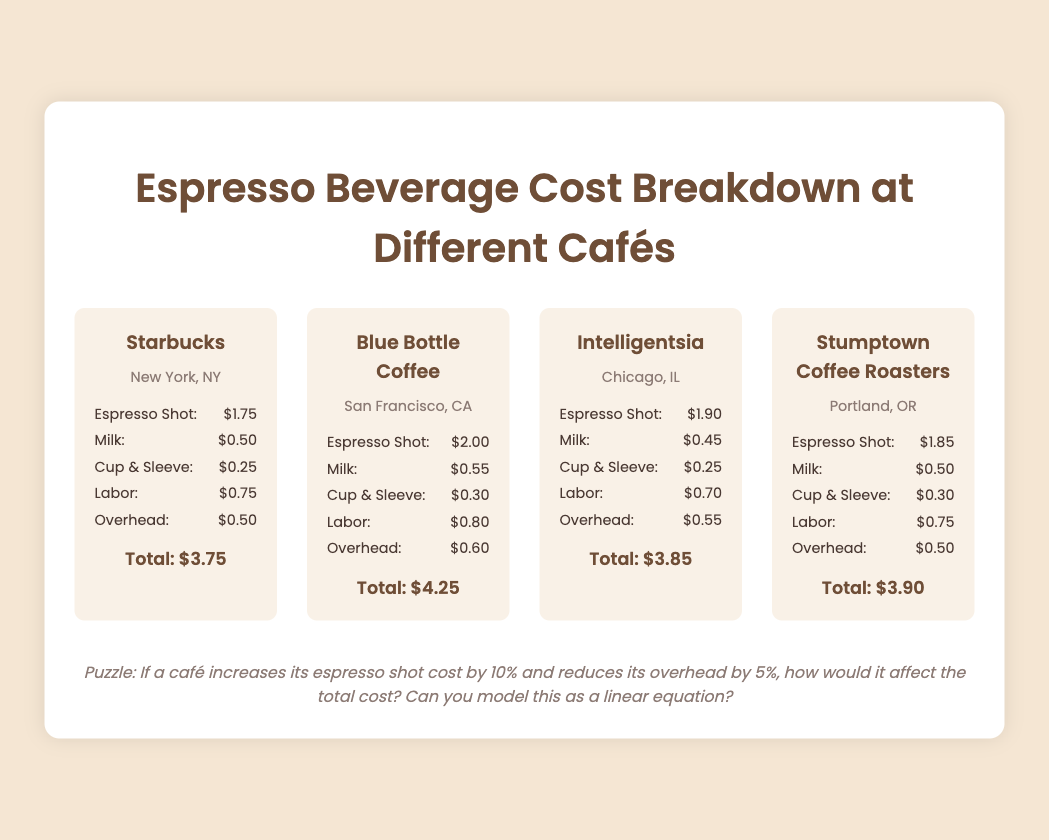What is the total cost of an espresso drink at Starbucks? The total cost at Starbucks is given in the cost breakdown, which shows a total of $3.75.
Answer: $3.75 What is the price of an espresso shot at Blue Bottle Coffee? The price of an espresso shot at Blue Bottle Coffee is provided in the cost breakdown, which states it is $2.00.
Answer: $2.00 Which café has the highest total cost for an espresso drink? The total costs for each café are compared, and Blue Bottle Coffee has the highest total cost at $4.25.
Answer: Blue Bottle Coffee How much is spent on labor at Intelligentsia? The document lists the labor cost at Intelligentsia, which is $0.70.
Answer: $0.70 What is the cost of the cup & sleeve at Stumptown Coffee Roasters? The cost of the cup and sleeve at Stumptown Coffee Roasters is specified in the cost breakdown as $0.30.
Answer: $0.30 Which café is located in New York? The document mentions Starbucks as the café located in New York, NY.
Answer: Starbucks If a café increases espresso shot cost by 10%, what does it imply about cost structure? The question relates to potential changes in overall costs based on adjustments to espresso shot price and overhead, indicating a need to analyze cost structure.
Answer: Cost structure analysis What is the main focus of this infographic document? The infographic specifically compares the cost breakdown of espresso beverages across different cafés.
Answer: Espresso beverage cost breakdown What city is associated with Intelligentsia? The document states that Intelligentsia is located in Chicago, IL.
Answer: Chicago, IL 